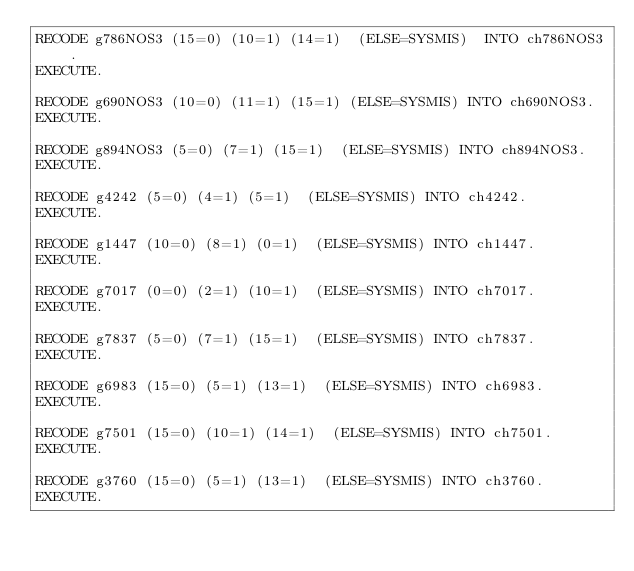Convert code to text. <code><loc_0><loc_0><loc_500><loc_500><_Scheme_>RECODE g786NOS3 (15=0) (10=1) (14=1)  (ELSE=SYSMIS)  INTO ch786NOS3. 
EXECUTE. 

RECODE g690NOS3 (10=0) (11=1) (15=1) (ELSE=SYSMIS) INTO ch690NOS3. 
EXECUTE. 

RECODE g894NOS3 (5=0) (7=1) (15=1)  (ELSE=SYSMIS) INTO ch894NOS3. 
EXECUTE. 

RECODE g4242 (5=0) (4=1) (5=1)  (ELSE=SYSMIS) INTO ch4242. 
EXECUTE. 

RECODE g1447 (10=0) (8=1) (0=1)  (ELSE=SYSMIS) INTO ch1447. 
EXECUTE. 

RECODE g7017 (0=0) (2=1) (10=1)  (ELSE=SYSMIS) INTO ch7017. 
EXECUTE. 

RECODE g7837 (5=0) (7=1) (15=1)  (ELSE=SYSMIS) INTO ch7837. 
EXECUTE. 

RECODE g6983 (15=0) (5=1) (13=1)  (ELSE=SYSMIS) INTO ch6983. 
EXECUTE. 
 
RECODE g7501 (15=0) (10=1) (14=1)  (ELSE=SYSMIS) INTO ch7501.
EXECUTE. 

RECODE g3760 (15=0) (5=1) (13=1)  (ELSE=SYSMIS) INTO ch3760.  
EXECUTE. 
</code> 